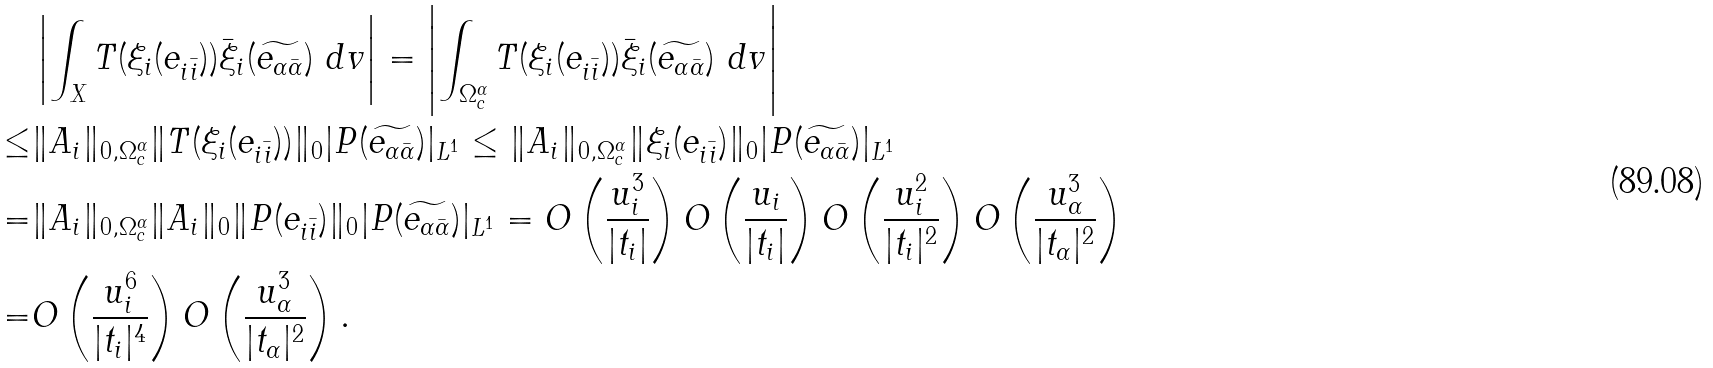Convert formula to latex. <formula><loc_0><loc_0><loc_500><loc_500>& \left | \int _ { X } T ( \xi _ { i } ( e _ { i \bar { i } } ) ) \bar { \xi } _ { i } ( \widetilde { e _ { \alpha \bar { \alpha } } } ) \ d v \right | = \left | \int _ { \Omega _ { c } ^ { \alpha } } T ( \xi _ { i } ( e _ { i \bar { i } } ) ) \bar { \xi } _ { i } ( \widetilde { e _ { \alpha \bar { \alpha } } } ) \ d v \right | \\ \leq & \| A _ { i } \| _ { 0 , \Omega _ { c } ^ { \alpha } } \| T ( \xi _ { i } ( e _ { i \bar { i } } ) ) \| _ { 0 } | P ( \widetilde { e _ { \alpha \bar { \alpha } } } ) | _ { L ^ { 1 } } \leq \| A _ { i } \| _ { 0 , \Omega _ { c } ^ { \alpha } } \| \xi _ { i } ( e _ { i \bar { i } } ) \| _ { 0 } | P ( \widetilde { e _ { \alpha \bar { \alpha } } } ) | _ { L ^ { 1 } } \\ = & \| A _ { i } \| _ { 0 , \Omega _ { c } ^ { \alpha } } \| A _ { i } \| _ { 0 } \| P ( e _ { i \bar { i } } ) \| _ { 0 } | P ( \widetilde { e _ { \alpha \bar { \alpha } } } ) | _ { L ^ { 1 } } = O \left ( \frac { u _ { i } ^ { 3 } } { | t _ { i } | } \right ) O \left ( \frac { u _ { i } } { | t _ { i } | } \right ) O \left ( \frac { u _ { i } ^ { 2 } } { | t _ { i } | ^ { 2 } } \right ) O \left ( \frac { u _ { \alpha } ^ { 3 } } { | t _ { \alpha } | ^ { 2 } } \right ) \\ = & O \left ( \frac { u _ { i } ^ { 6 } } { | t _ { i } | ^ { 4 } } \right ) O \left ( \frac { u _ { \alpha } ^ { 3 } } { | t _ { \alpha } | ^ { 2 } } \right ) .</formula> 